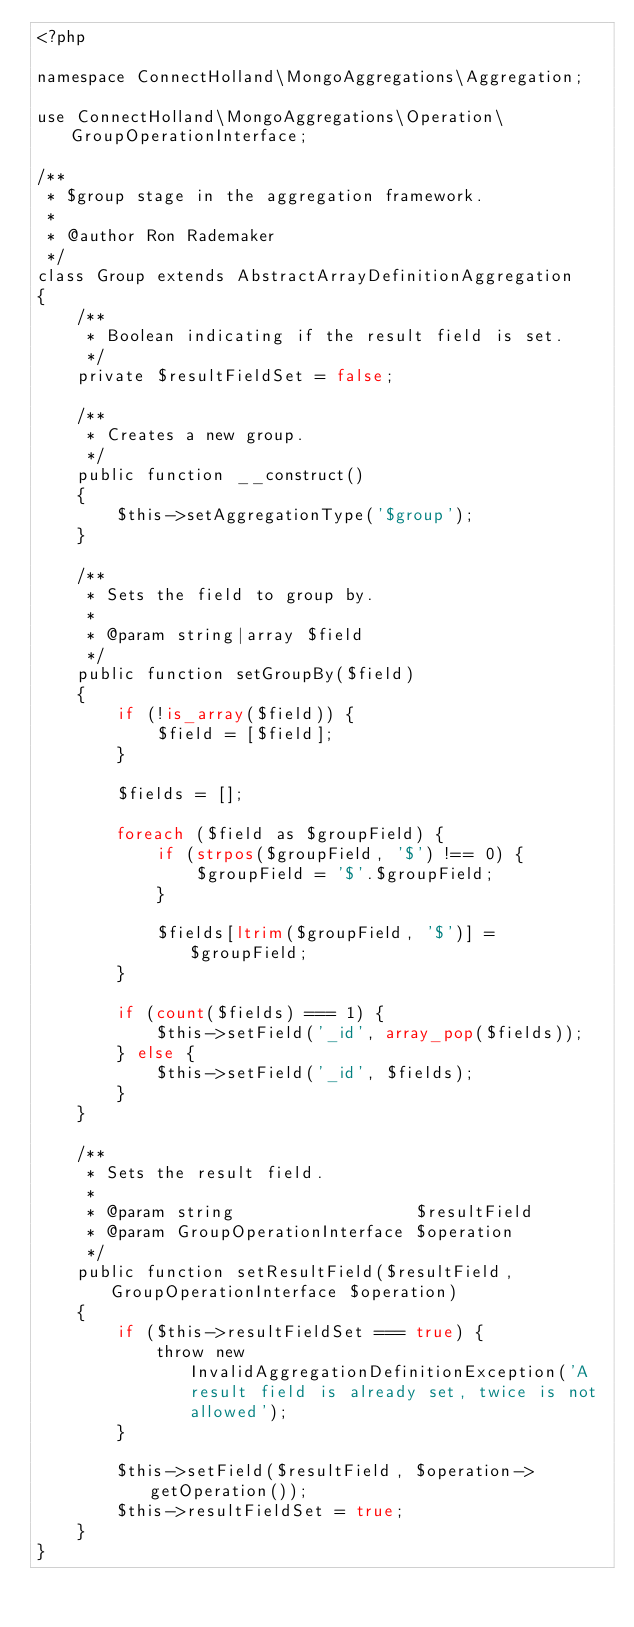Convert code to text. <code><loc_0><loc_0><loc_500><loc_500><_PHP_><?php

namespace ConnectHolland\MongoAggregations\Aggregation;

use ConnectHolland\MongoAggregations\Operation\GroupOperationInterface;

/**
 * $group stage in the aggregation framework.
 *
 * @author Ron Rademaker
 */
class Group extends AbstractArrayDefinitionAggregation
{
    /**
     * Boolean indicating if the result field is set.
     */
    private $resultFieldSet = false;

    /**
     * Creates a new group.
     */
    public function __construct()
    {
        $this->setAggregationType('$group');
    }

    /**
     * Sets the field to group by.
     *
     * @param string|array $field
     */
    public function setGroupBy($field)
    {
        if (!is_array($field)) {
            $field = [$field];
        }

        $fields = [];

        foreach ($field as $groupField) {
            if (strpos($groupField, '$') !== 0) {
                $groupField = '$'.$groupField;
            }

            $fields[ltrim($groupField, '$')] = $groupField;
        }

        if (count($fields) === 1) {
            $this->setField('_id', array_pop($fields));
        } else {
            $this->setField('_id', $fields);
        }
    }

    /**
     * Sets the result field.
     *
     * @param string                  $resultField
     * @param GroupOperationInterface $operation
     */
    public function setResultField($resultField, GroupOperationInterface $operation)
    {
        if ($this->resultFieldSet === true) {
            throw new InvalidAggregationDefinitionException('A result field is already set, twice is not allowed');
        }

        $this->setField($resultField, $operation->getOperation());
        $this->resultFieldSet = true;
    }
}
</code> 